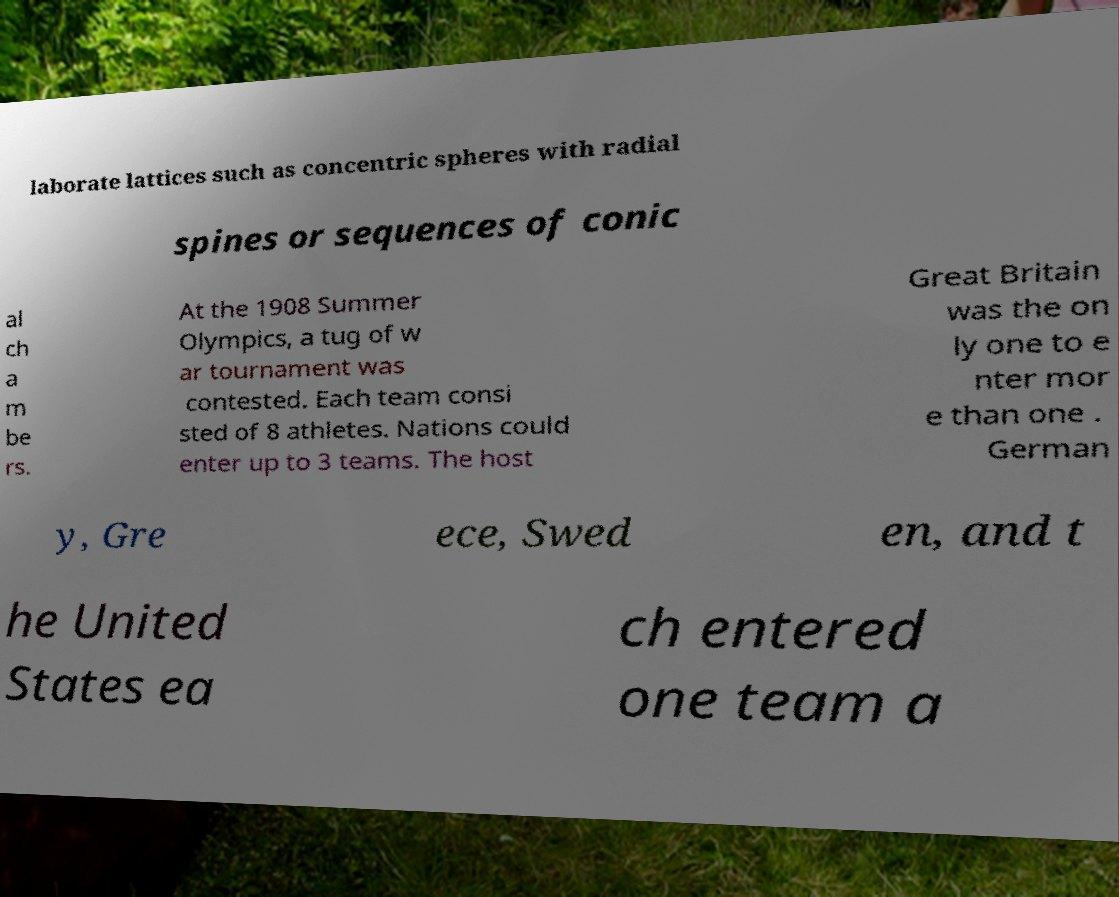Can you read and provide the text displayed in the image?This photo seems to have some interesting text. Can you extract and type it out for me? laborate lattices such as concentric spheres with radial spines or sequences of conic al ch a m be rs. At the 1908 Summer Olympics, a tug of w ar tournament was contested. Each team consi sted of 8 athletes. Nations could enter up to 3 teams. The host Great Britain was the on ly one to e nter mor e than one . German y, Gre ece, Swed en, and t he United States ea ch entered one team a 